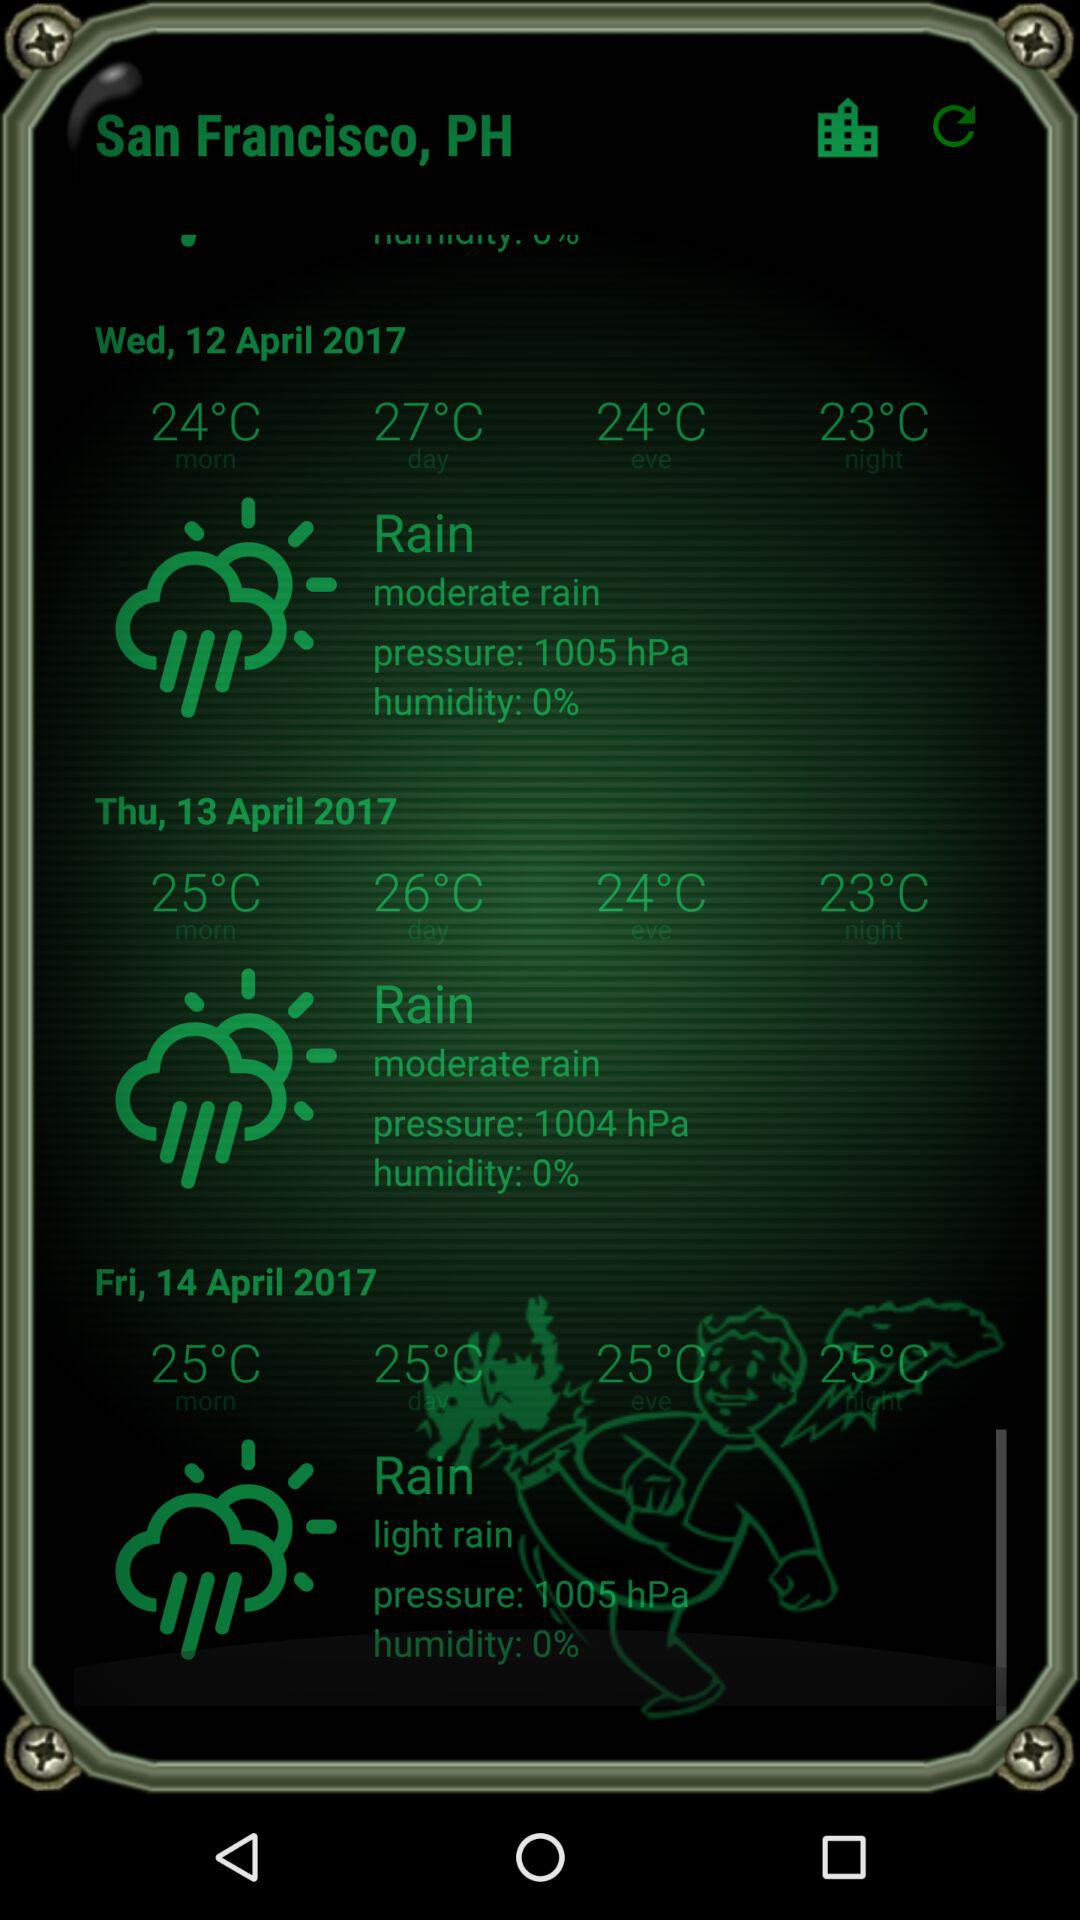What is the location? The location is San Francisco, PH. 